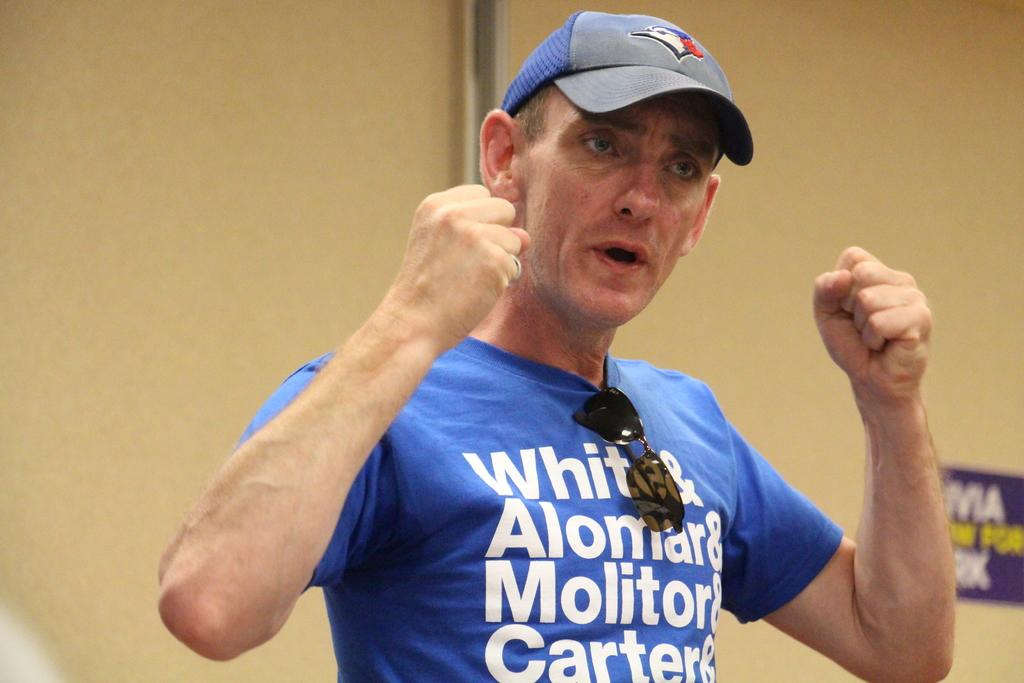Provide a one-sentence caption for the provided image. A man wears a blue shirt that says White&Alomar&Molitor&Carter&. 